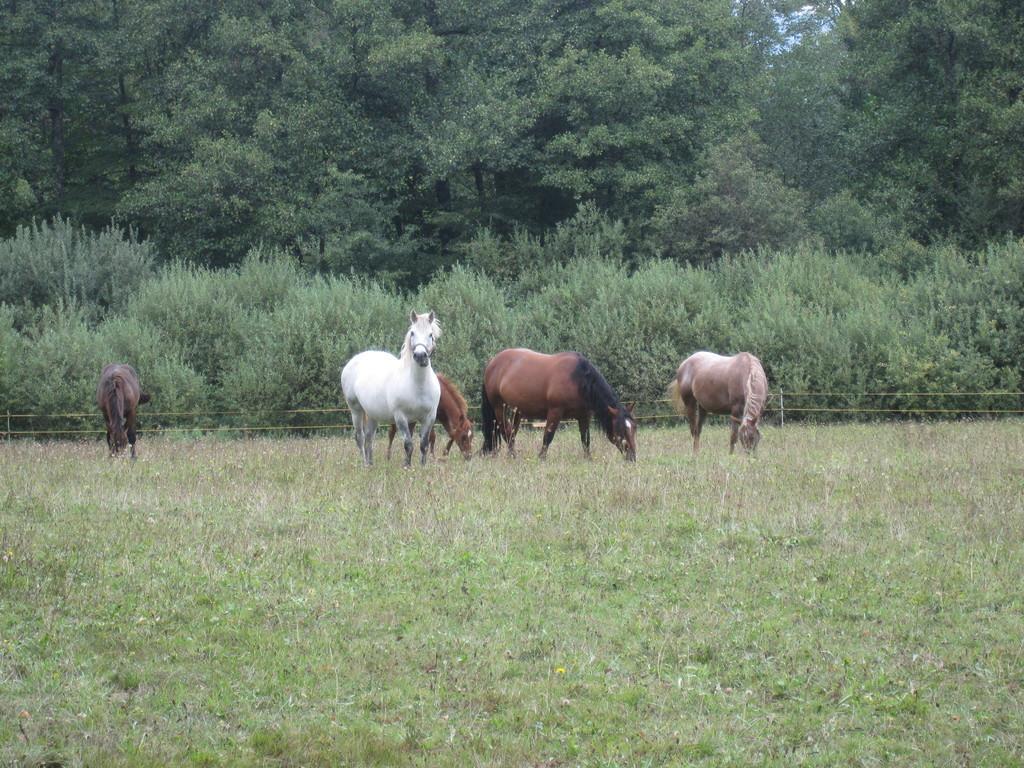Could you give a brief overview of what you see in this image? This picture is clicked outside the city. In the foreground we can see the grass. In the center there are some animals standing on the ground and some of them seems to be eating the grass. In the background we can see the trees and the plants. 